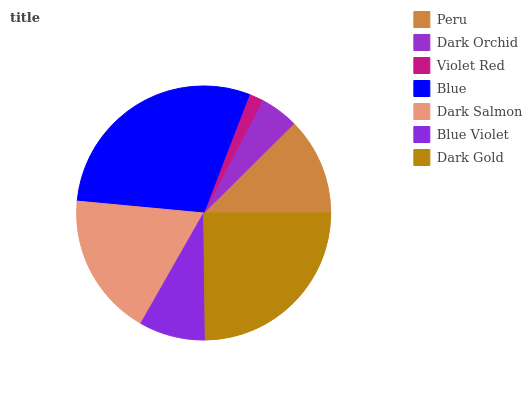Is Violet Red the minimum?
Answer yes or no. Yes. Is Blue the maximum?
Answer yes or no. Yes. Is Dark Orchid the minimum?
Answer yes or no. No. Is Dark Orchid the maximum?
Answer yes or no. No. Is Peru greater than Dark Orchid?
Answer yes or no. Yes. Is Dark Orchid less than Peru?
Answer yes or no. Yes. Is Dark Orchid greater than Peru?
Answer yes or no. No. Is Peru less than Dark Orchid?
Answer yes or no. No. Is Peru the high median?
Answer yes or no. Yes. Is Peru the low median?
Answer yes or no. Yes. Is Blue the high median?
Answer yes or no. No. Is Dark Gold the low median?
Answer yes or no. No. 